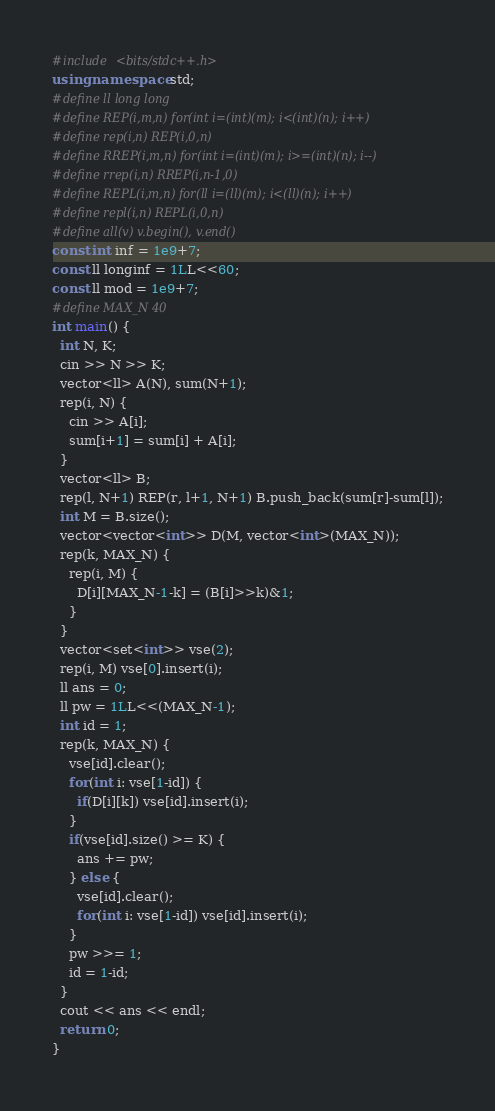Convert code to text. <code><loc_0><loc_0><loc_500><loc_500><_C++_>#include <bits/stdc++.h>
using namespace std;
#define ll long long
#define REP(i,m,n) for(int i=(int)(m); i<(int)(n); i++)
#define rep(i,n) REP(i,0,n)
#define RREP(i,m,n) for(int i=(int)(m); i>=(int)(n); i--)
#define rrep(i,n) RREP(i,n-1,0)
#define REPL(i,m,n) for(ll i=(ll)(m); i<(ll)(n); i++)
#define repl(i,n) REPL(i,0,n)
#define all(v) v.begin(), v.end()
const int inf = 1e9+7;
const ll longinf = 1LL<<60;
const ll mod = 1e9+7;
#define MAX_N 40
int main() {
  int N, K;
  cin >> N >> K;
  vector<ll> A(N), sum(N+1);
  rep(i, N) {
    cin >> A[i];
    sum[i+1] = sum[i] + A[i];
  }
  vector<ll> B;
  rep(l, N+1) REP(r, l+1, N+1) B.push_back(sum[r]-sum[l]);
  int M = B.size();
  vector<vector<int>> D(M, vector<int>(MAX_N));
  rep(k, MAX_N) {
    rep(i, M) {
      D[i][MAX_N-1-k] = (B[i]>>k)&1;
    }
  }
  vector<set<int>> vse(2);
  rep(i, M) vse[0].insert(i);
  ll ans = 0;
  ll pw = 1LL<<(MAX_N-1);
  int id = 1;
  rep(k, MAX_N) {
    vse[id].clear();
    for(int i: vse[1-id]) {
      if(D[i][k]) vse[id].insert(i);
    }
    if(vse[id].size() >= K) {
      ans += pw;
    } else {
      vse[id].clear();
      for(int i: vse[1-id]) vse[id].insert(i);
    }
    pw >>= 1;
    id = 1-id;
  }
  cout << ans << endl;
  return 0;
}
</code> 